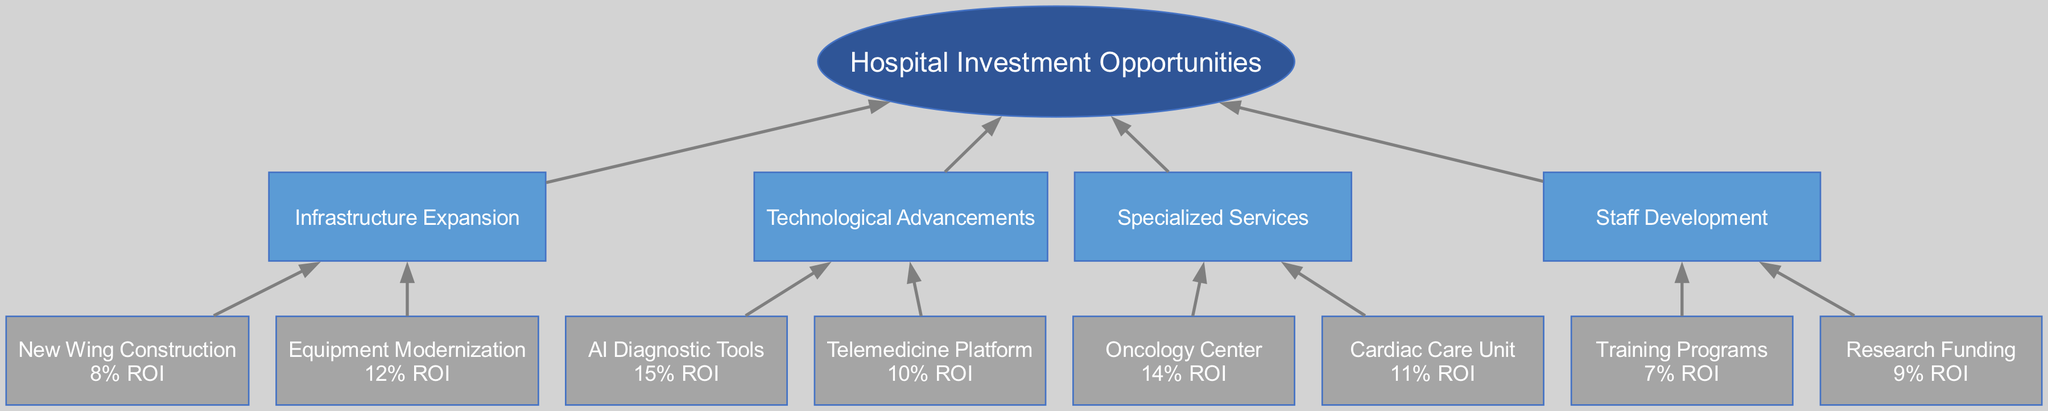What is the ROI for AI Diagnostic Tools? The subbranch labeled "AI Diagnostic Tools" under the "Technological Advancements" branch shows a return of "15% ROI". Therefore, we can directly read this value from the diagram.
Answer: 15% ROI Which investment area has the highest projected return? By examining all the subbranches, the "AI Diagnostic Tools" has the highest ROI of "15% ROI", more than any other subbranches. Therefore it stands out as the top investment area in terms of return.
Answer: AI Diagnostic Tools How many subbranches does the "Infrastructure Expansion" branch have? The "Infrastructure Expansion" branch contains two subbranches: "New Wing Construction" and "Equipment Modernization". Counting these gives a total of two subbranches for this branch.
Answer: 2 What is the ROI of the Cardiac Care Unit? The subbranch "Cardiac Care Unit" under the "Specialized Services" branch displays "11% ROI". Read this value from the diagram directly for the answer.
Answer: 11% ROI What is the relationship between "Telemedicine Platform" and "Technological Advancements"? The "Telemedicine Platform" is a subbranch that falls under the larger "Technological Advancements" branch, indicating a direct connection of it as a focused area for investment in technology improvements.
Answer: Subbranch of Technological Advancements Which branch has the lowest projected return? The "Staff Development" branch has the lowest ROI in its subbranches, with "Training Programs" offering "7% ROI", which is lower than all other branches’ subbranches. Thus, this branch shows the least financial return.
Answer: Staff Development How many total branches are there in the diagram? There are four primary branches listed in the diagram: "Infrastructure Expansion", "Technological Advancements", "Specialized Services", and "Staff Development". Counting them gives us a total of four branches.
Answer: 4 What is the return for the Equipment Modernization? The subbranch labeled "Equipment Modernization" under the "Infrastructure Expansion" branch shows a return of "12% ROI". This data can be directly retrieved from the diagram.
Answer: 12% ROI Which investment area focuses on patient care services? The "Specialized Services" area includes specific patient care services such as "Oncology Center" and "Cardiac Care Unit". This focus on direct health services means it is aligned with patient care investment.
Answer: Specialized Services 